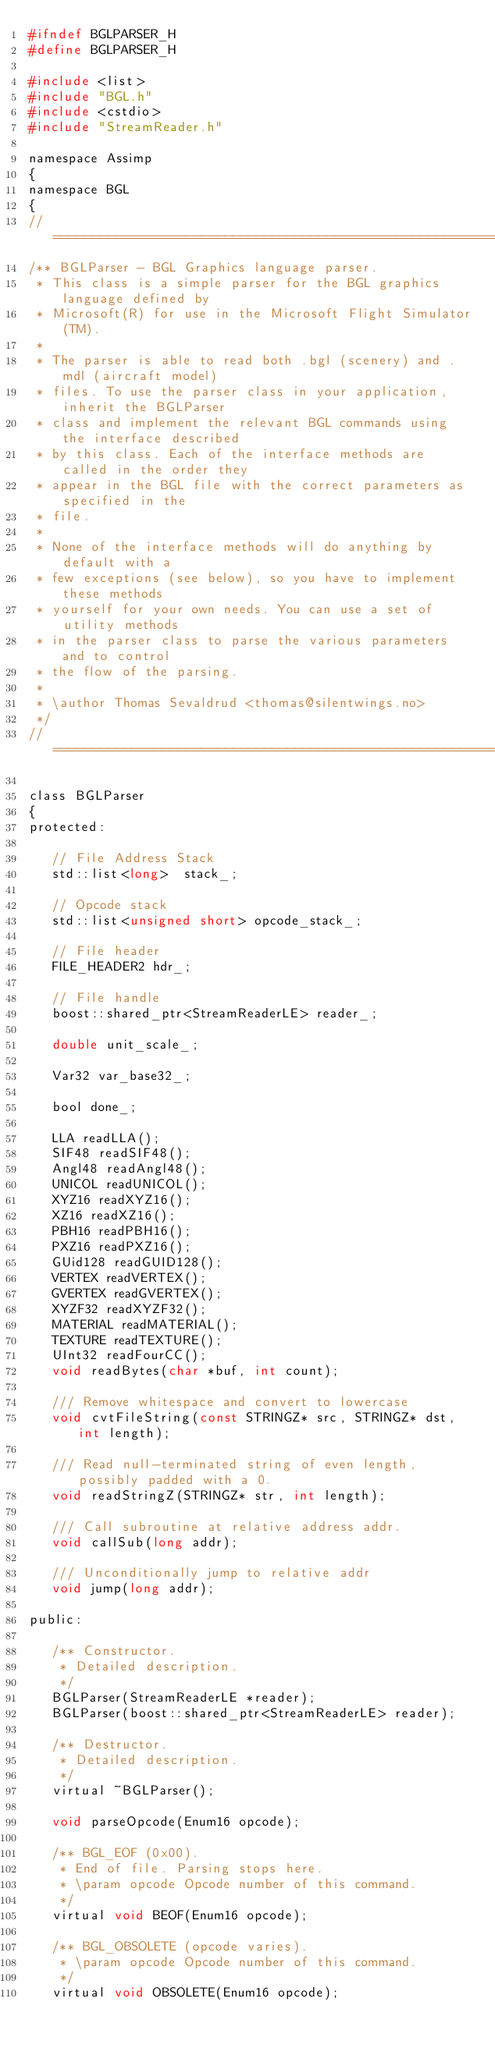Convert code to text. <code><loc_0><loc_0><loc_500><loc_500><_C_>#ifndef BGLPARSER_H
#define BGLPARSER_H

#include <list>
#include "BGL.h"
#include <cstdio>
#include "StreamReader.h"

namespace Assimp
{
namespace BGL
{
//===========================================================================
/** BGLParser - BGL Graphics language parser.
 * This class is a simple parser for the BGL graphics language defined by
 * Microsoft(R) for use in the Microsoft Flight Simulator(TM).
 *
 * The parser is able to read both .bgl (scenery) and .mdl (aircraft model)
 * files. To use the parser class in your application, inherit the BGLParser
 * class and implement the relevant BGL commands using the interface described
 * by this class. Each of the interface methods are called in the order they
 * appear in the BGL file with the correct parameters as specified in the
 * file.
 *
 * None of the interface methods will do anything by default with a
 * few exceptions (see below), so you have to implement these methods
 * yourself for your own needs. You can use a set of utility methods
 * in the parser class to parse the various parameters and to control
 * the flow of the parsing.
 *
 * \author Thomas Sevaldrud <thomas@silentwings.no>
 */
//===========================================================================

class BGLParser
{
protected:

   // File Address Stack
   std::list<long> 	stack_;

   // Opcode stack
   std::list<unsigned short> opcode_stack_;

   // File header
   FILE_HEADER2 hdr_;

   // File handle
   boost::shared_ptr<StreamReaderLE> reader_;

   double unit_scale_;

   Var32 var_base32_;

   bool done_;

   LLA readLLA();
   SIF48 readSIF48();
   Angl48 readAngl48();
   UNICOL readUNICOL();
   XYZ16 readXYZ16();
   XZ16 readXZ16();
   PBH16 readPBH16();
   PXZ16 readPXZ16();
   GUid128 readGUID128();
   VERTEX readVERTEX();
   GVERTEX readGVERTEX();
   XYZF32 readXYZF32();
   MATERIAL readMATERIAL();
   TEXTURE readTEXTURE();
   UInt32 readFourCC();
   void readBytes(char *buf, int count);

   /// Remove whitespace and convert to lowercase
   void cvtFileString(const STRINGZ* src, STRINGZ* dst, int length);

   /// Read null-terminated string of even length, possibly padded with a 0.
   void readStringZ(STRINGZ* str, int length);

   /// Call subroutine at relative address addr.
   void callSub(long addr);

   /// Unconditionally jump to relative addr
   void jump(long addr);

public:

   /** Constructor.
    * Detailed description.
    */
   BGLParser(StreamReaderLE *reader);
   BGLParser(boost::shared_ptr<StreamReaderLE> reader);

   /** Destructor.
    * Detailed description.
    */
   virtual ~BGLParser();

   void parseOpcode(Enum16 opcode);

   /** BGL_EOF (0x00).
    * End of file. Parsing stops here.
    * \param opcode Opcode number of this command.
    */
   virtual void BEOF(Enum16 opcode);

   /** BGL_OBSOLETE (opcode varies).
    * \param opcode Opcode number of this command.
    */
   virtual void OBSOLETE(Enum16 opcode);
</code> 